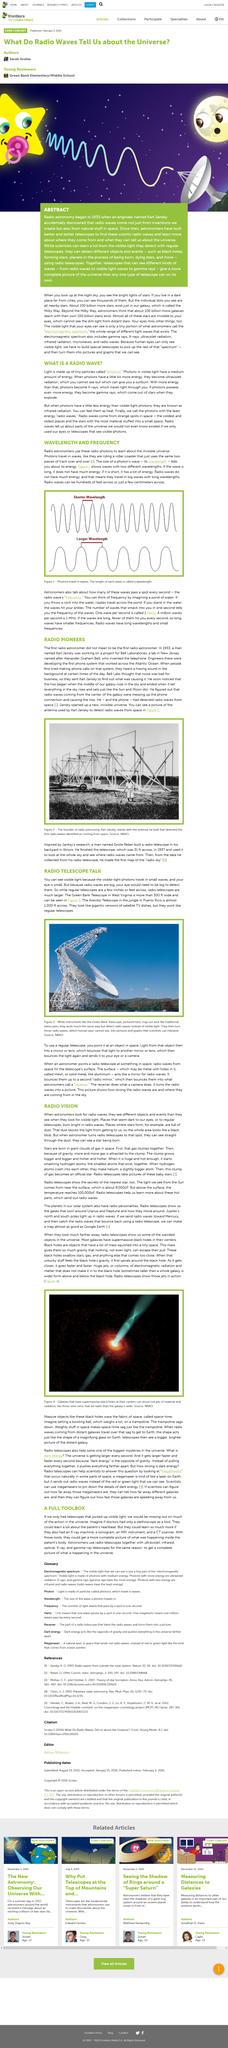List a handful of essential elements in this visual. The Green Bank Telescope in West Virginia, with a width of 300 feet, is more than just a scientific instrument. The size of a photon's wave is referred to as its wavelength. Photons travel in waves. A radio telescope has the ability to circumvent the obstruction of dust in space, rendering it an advantage over a regular light-based telescope. The title "Radio Vision" refers to astronomers using radio telescopes to detect radio waves emitted by celestial objects, such as stars and galaxies, in order to study their properties and behavior. 